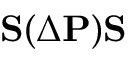Convert formula to latex. <formula><loc_0><loc_0><loc_500><loc_500>{ S } ( \Delta { P } ) { S }</formula> 